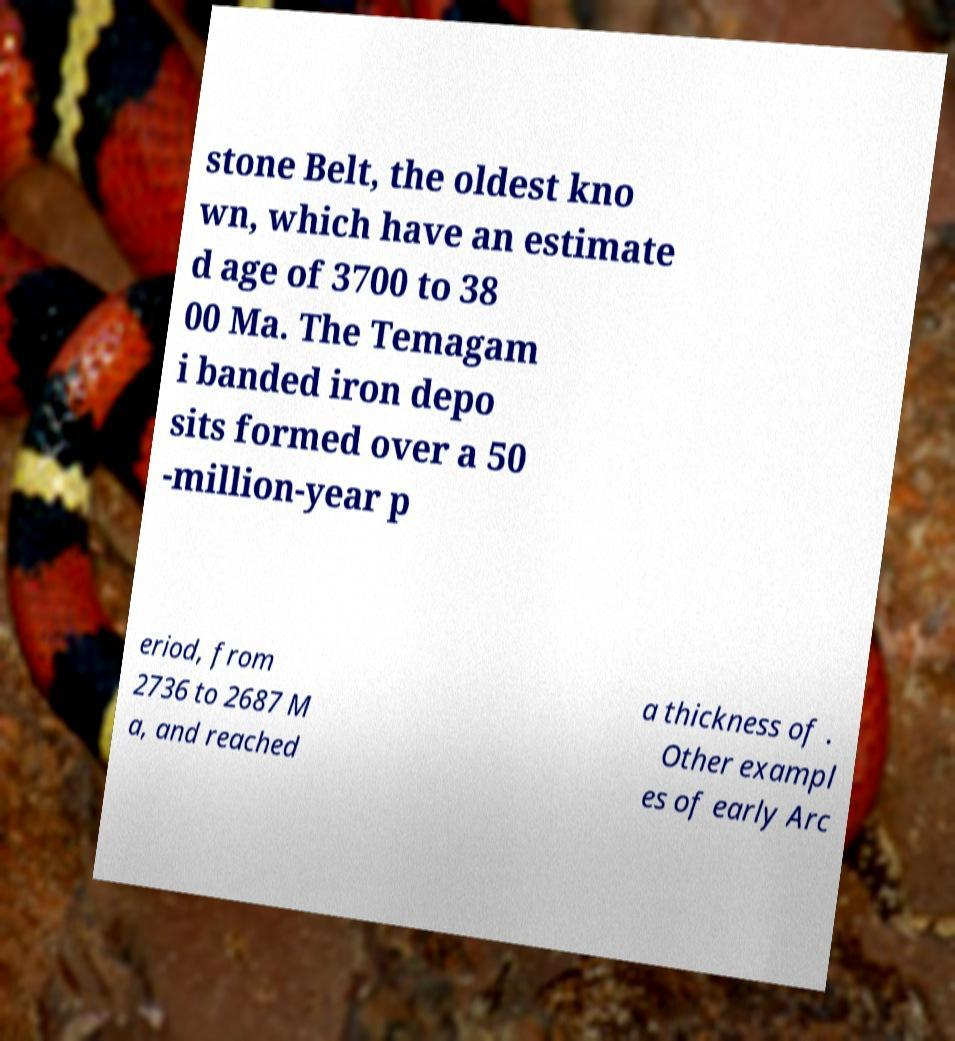Could you extract and type out the text from this image? stone Belt, the oldest kno wn, which have an estimate d age of 3700 to 38 00 Ma. The Temagam i banded iron depo sits formed over a 50 -million-year p eriod, from 2736 to 2687 M a, and reached a thickness of . Other exampl es of early Arc 